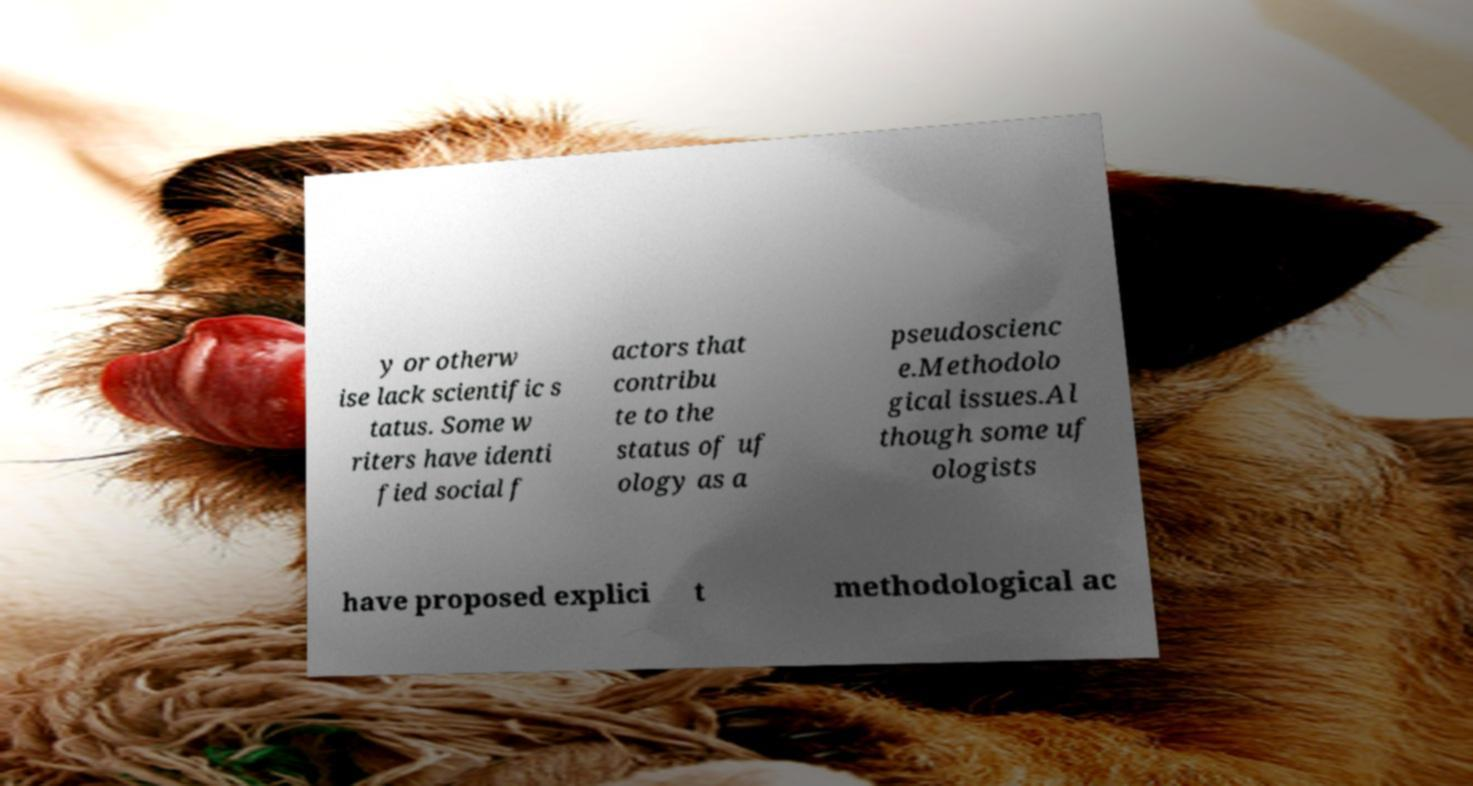Can you read and provide the text displayed in the image?This photo seems to have some interesting text. Can you extract and type it out for me? y or otherw ise lack scientific s tatus. Some w riters have identi fied social f actors that contribu te to the status of uf ology as a pseudoscienc e.Methodolo gical issues.Al though some uf ologists have proposed explici t methodological ac 